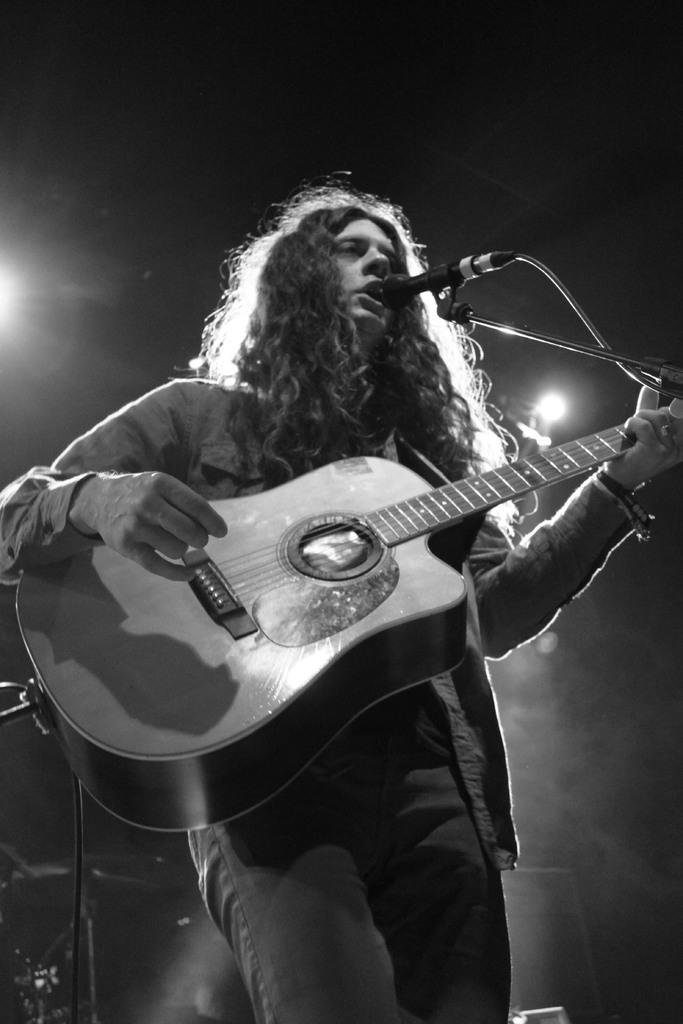What is the person in the image doing? The person is standing, singing, and playing the guitar. What instrument is the person holding in the image? The person is holding a guitar in the image. Where is the microphone stand located in the image? The microphone stand is on the right side of the image. What type of coil is being used to generate income in the image? There is no coil or mention of generating income in the image; it features a person singing and playing the guitar. What type of feast is being prepared in the image? There is no feast or preparation of food visible in the image. 